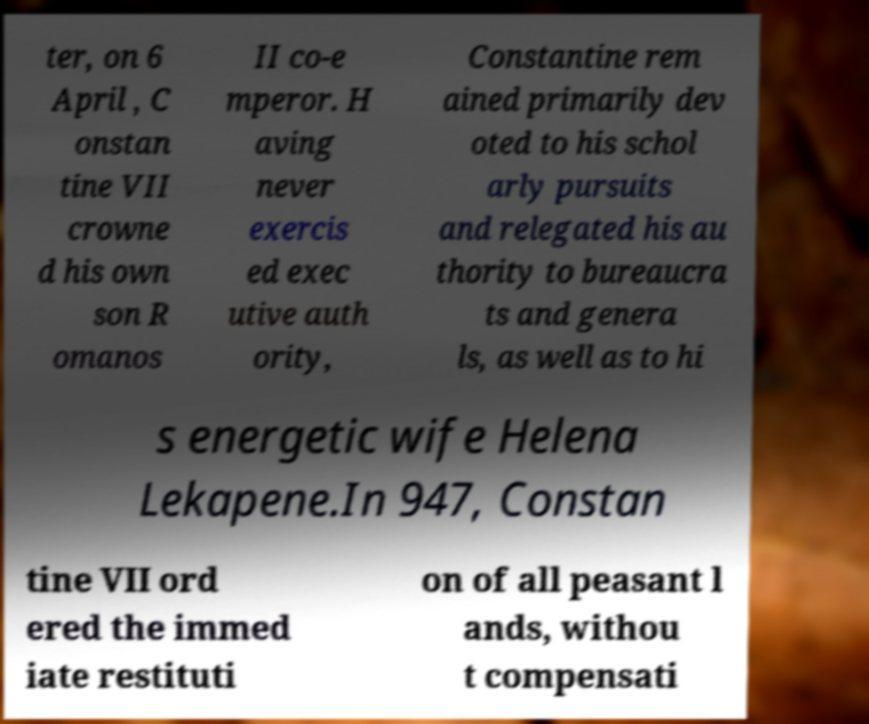Can you accurately transcribe the text from the provided image for me? ter, on 6 April , C onstan tine VII crowne d his own son R omanos II co-e mperor. H aving never exercis ed exec utive auth ority, Constantine rem ained primarily dev oted to his schol arly pursuits and relegated his au thority to bureaucra ts and genera ls, as well as to hi s energetic wife Helena Lekapene.In 947, Constan tine VII ord ered the immed iate restituti on of all peasant l ands, withou t compensati 